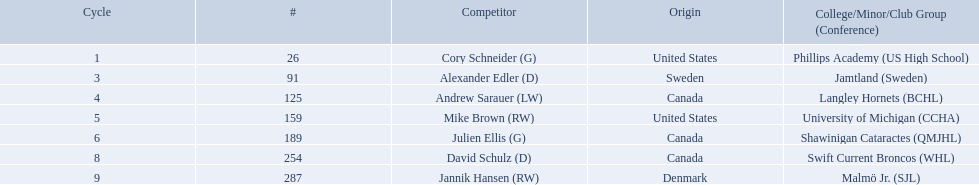What are the nationalities of the players? United States, Sweden, Canada, United States, Canada, Canada, Denmark. Of the players, which one lists his nationality as denmark? Jannik Hansen (RW). 